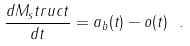<formula> <loc_0><loc_0><loc_500><loc_500>\frac { d M _ { s } t r u c t } { d t } = a _ { b } ( t ) - o ( t ) \ .</formula> 